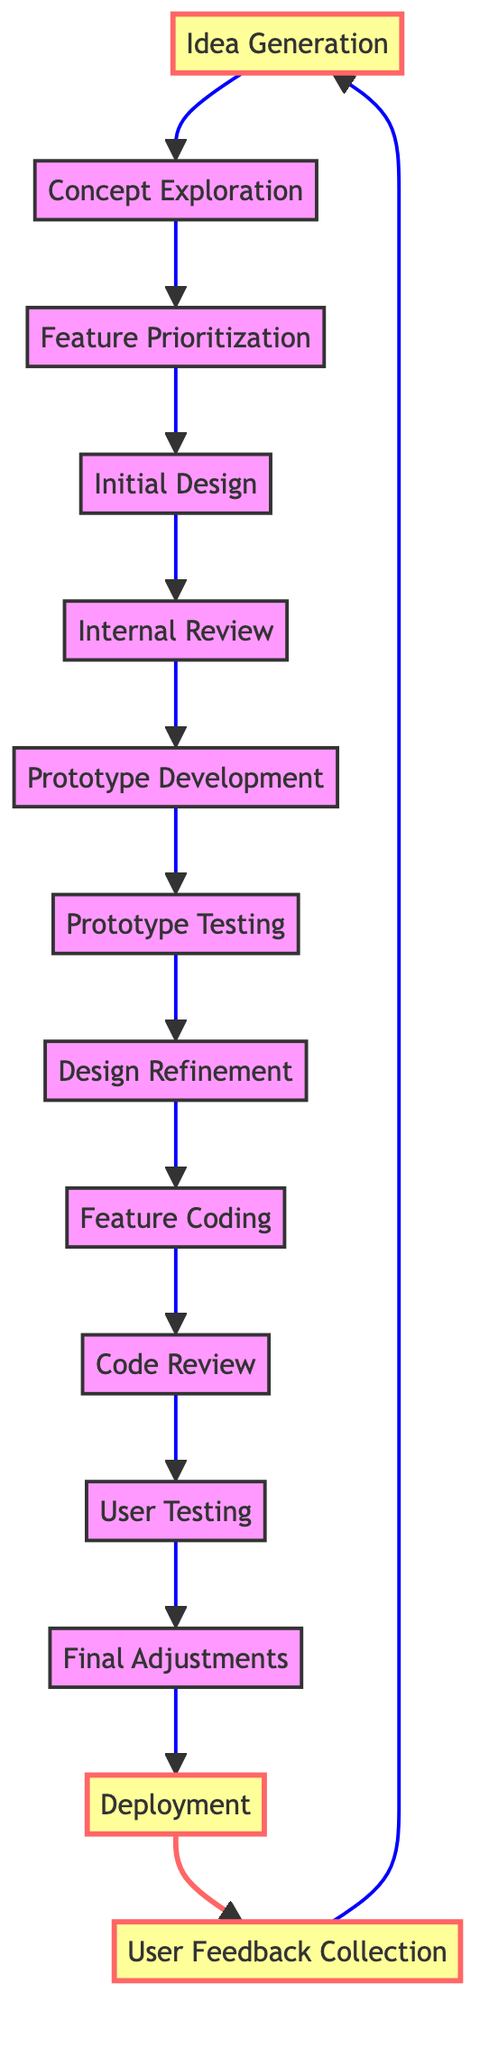What is the first step in the workflow? The diagram clearly indicates that the first step is "Idea Generation," which is the starting node in the flow.
Answer: Idea Generation How many total steps are present in the workflow? By counting the nodes listed in the diagram, there are a total of 13 steps from "Idea Generation" to "User Feedback Collection."
Answer: 13 Which step follows "Prototype Testing"? Following the node "Prototype Testing," the next step in the workflow is "Design Refinement," which is directly connected to it in the diagram.
Answer: Design Refinement What is the last step before deployment? The last step before "Deployment" is "Final Adjustments," which comes immediately before it based on the flow of the diagram.
Answer: Final Adjustments What connects "Feature Coding" to "User Testing"? "Code Review" is the step that connects "Feature Coding" to "User Testing" as indicated by the directed edge in the diagram.
Answer: Code Review Which two steps are highlighted in the diagram? The highlighted steps in the diagram are "Idea Generation" and "Deployment," emphasized for importance in the workflow.
Answer: Idea Generation, Deployment What is the purpose of "User Feedback Collection"? The step "User Feedback Collection" serves to gather feedback from users after deployment, which is its specific function according to the diagram.
Answer: Gather feedback from users What happens after “User Testing”? After "User Testing," the next action in the flow is to make "Final Adjustments," based on the feedback gathered from user testing.
Answer: Final Adjustments Which step occurs after "Internal Review"? The step that directly follows "Internal Review" in the workflow is "Prototype Development," as per the connections outlined in the diagram.
Answer: Prototype Development 